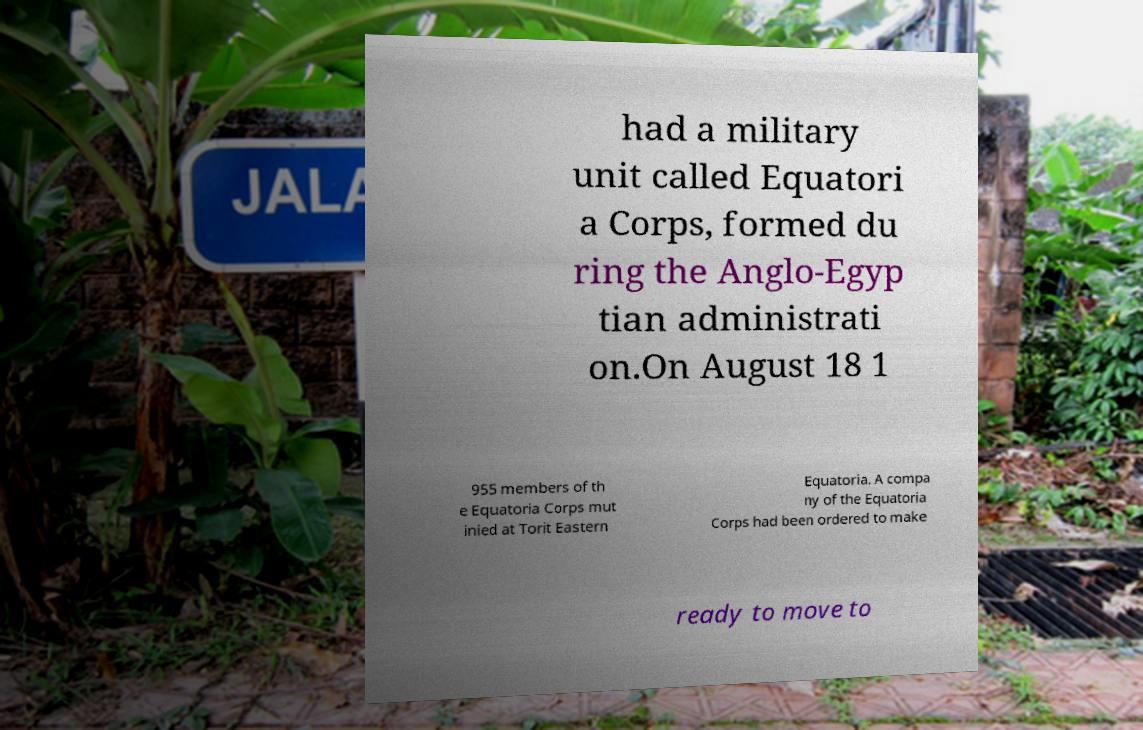Can you accurately transcribe the text from the provided image for me? had a military unit called Equatori a Corps, formed du ring the Anglo-Egyp tian administrati on.On August 18 1 955 members of th e Equatoria Corps mut inied at Torit Eastern Equatoria. A compa ny of the Equatoria Corps had been ordered to make ready to move to 